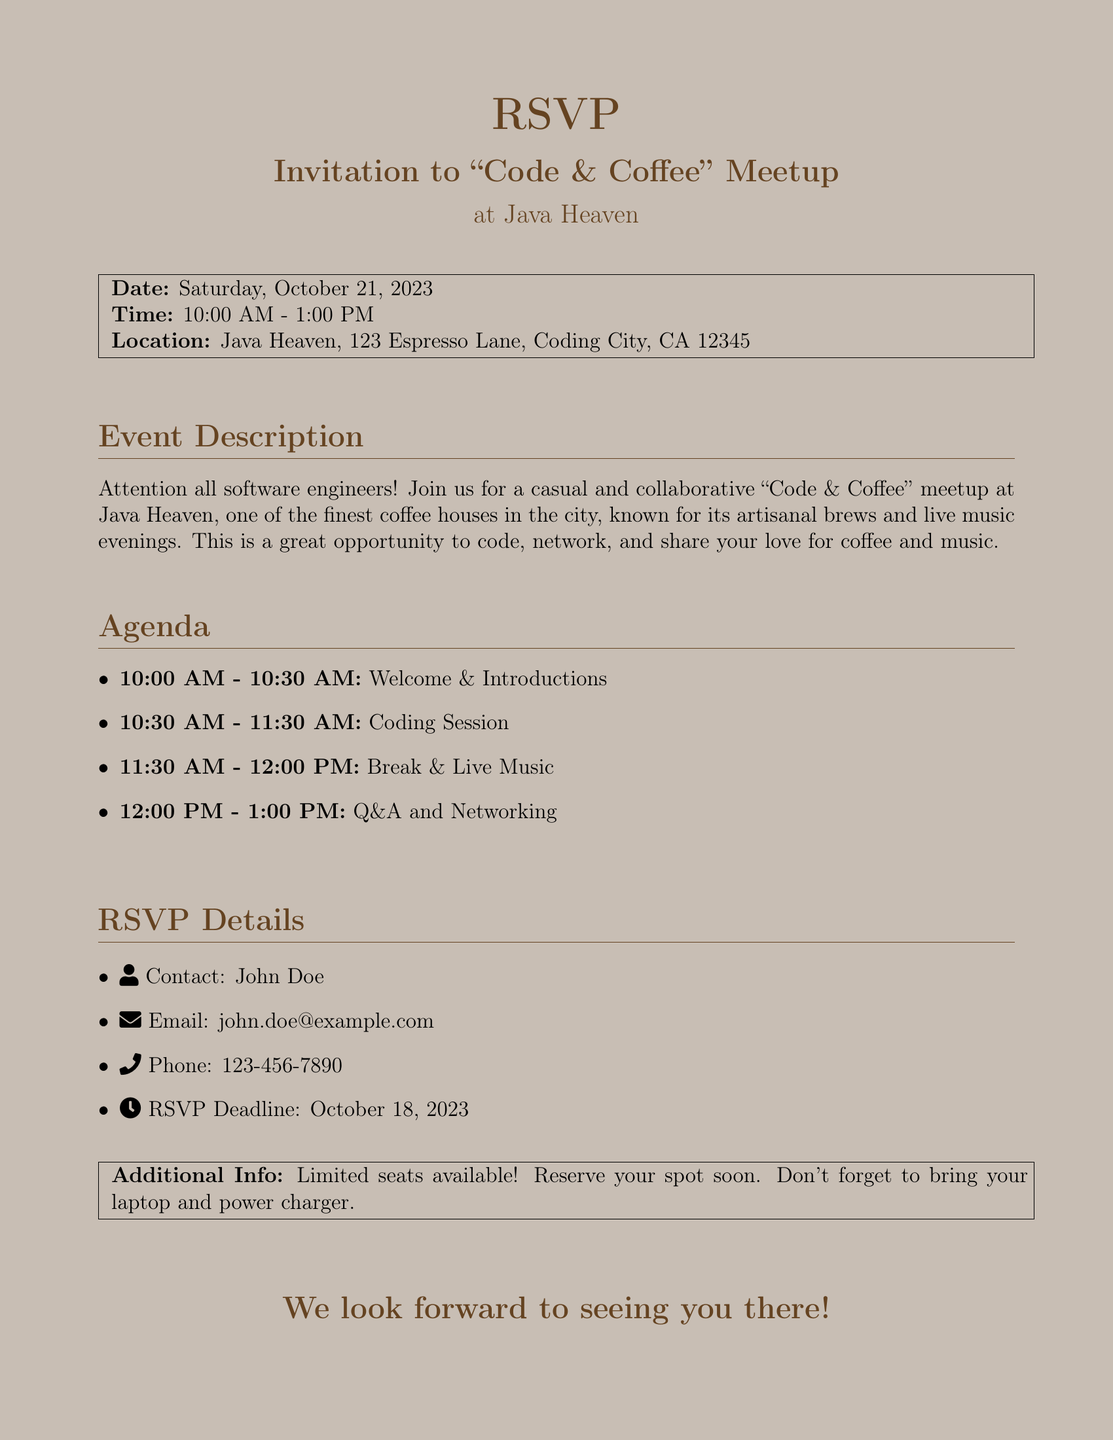What is the date of the meetup? The date of the meetup is specified in the document as Saturday, October 21, 2023.
Answer: Saturday, October 21, 2023 What time does the event start? The time when the event begins is mentioned in the document, which is 10:00 AM.
Answer: 10:00 AM Where is the location of the meetup? The location for the meetup is provided in the document as Java Heaven, 123 Espresso Lane, Coding City, CA 12345.
Answer: Java Heaven, 123 Espresso Lane, Coding City, CA 12345 Who is the contact for RSVP inquiries? The contact person's name for RSVPs is included in the document, which is John Doe.
Answer: John Doe What is the RSVP deadline? The deadline for RSVPs is mentioned in the document, which is October 18, 2023.
Answer: October 18, 2023 How long is the coding session scheduled for? The coding session duration is provided in the agenda section, which states it lasts for one hour.
Answer: one hour What type of event is this? The type of event is indicated in the title and description as a "Code & Coffee" meetup.
Answer: "Code & Coffee" meetup What should attendees bring to the event? The document advises attendees to bring their laptop and power charger.
Answer: laptop and power charger Is there a limit to the number of attendees? The document states that limited seats are available, indicating a restriction on the number of attendees.
Answer: Limited seats available 